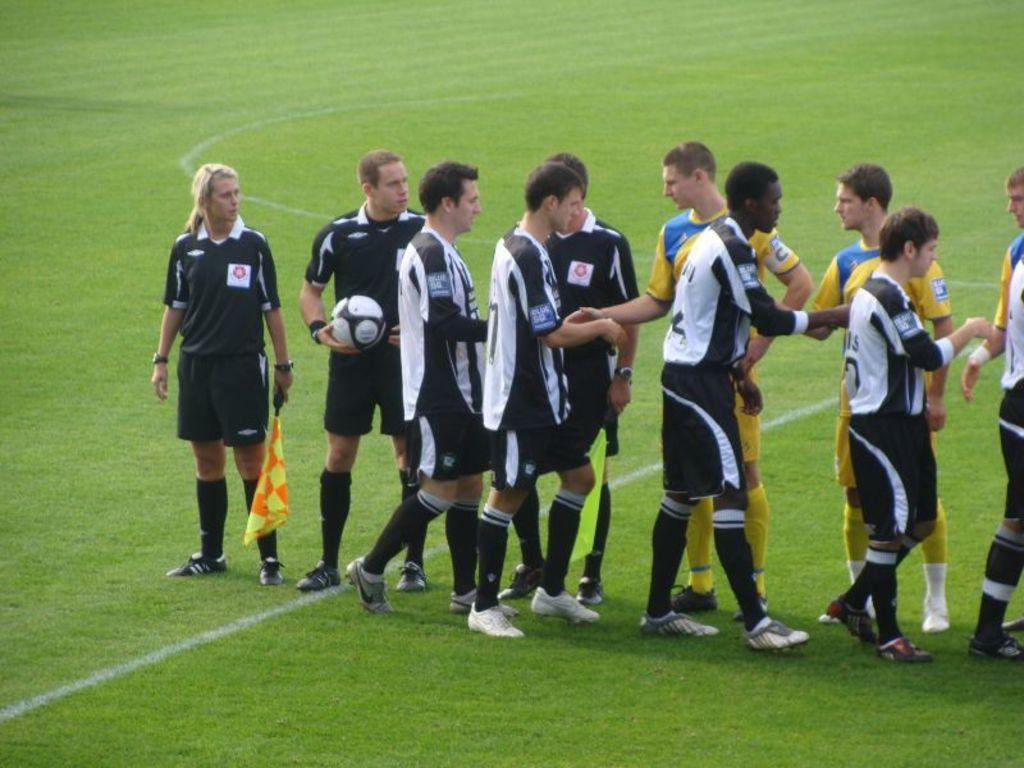How many groups of players are present in the image? There are two teams in the image. What are the players doing in the image? The players are greeting each other. Who is holding the ball in the image? A man is holding a ball in the image. Where are the players assembled in the image? The people are assembled in a ground. What type of canvas is being used by the father in the image? There is no father or canvas present in the image. What type of work are the players engaged in during the image? The players are not engaged in any work; they are greeting each other in a sports context. 